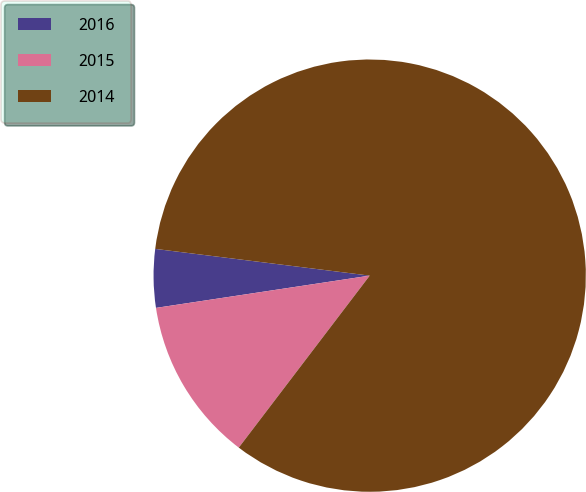Convert chart to OTSL. <chart><loc_0><loc_0><loc_500><loc_500><pie_chart><fcel>2016<fcel>2015<fcel>2014<nl><fcel>4.36%<fcel>12.26%<fcel>83.39%<nl></chart> 